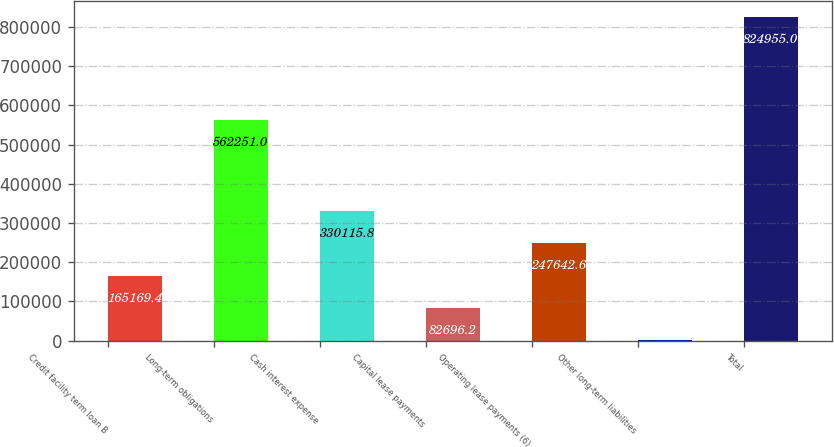<chart> <loc_0><loc_0><loc_500><loc_500><bar_chart><fcel>Credit facility term loan B<fcel>Long-term obligations<fcel>Cash interest expense<fcel>Capital lease payments<fcel>Operating lease payments (6)<fcel>Other long-term liabilities<fcel>Total<nl><fcel>165169<fcel>562251<fcel>330116<fcel>82696.2<fcel>247643<fcel>223<fcel>824955<nl></chart> 